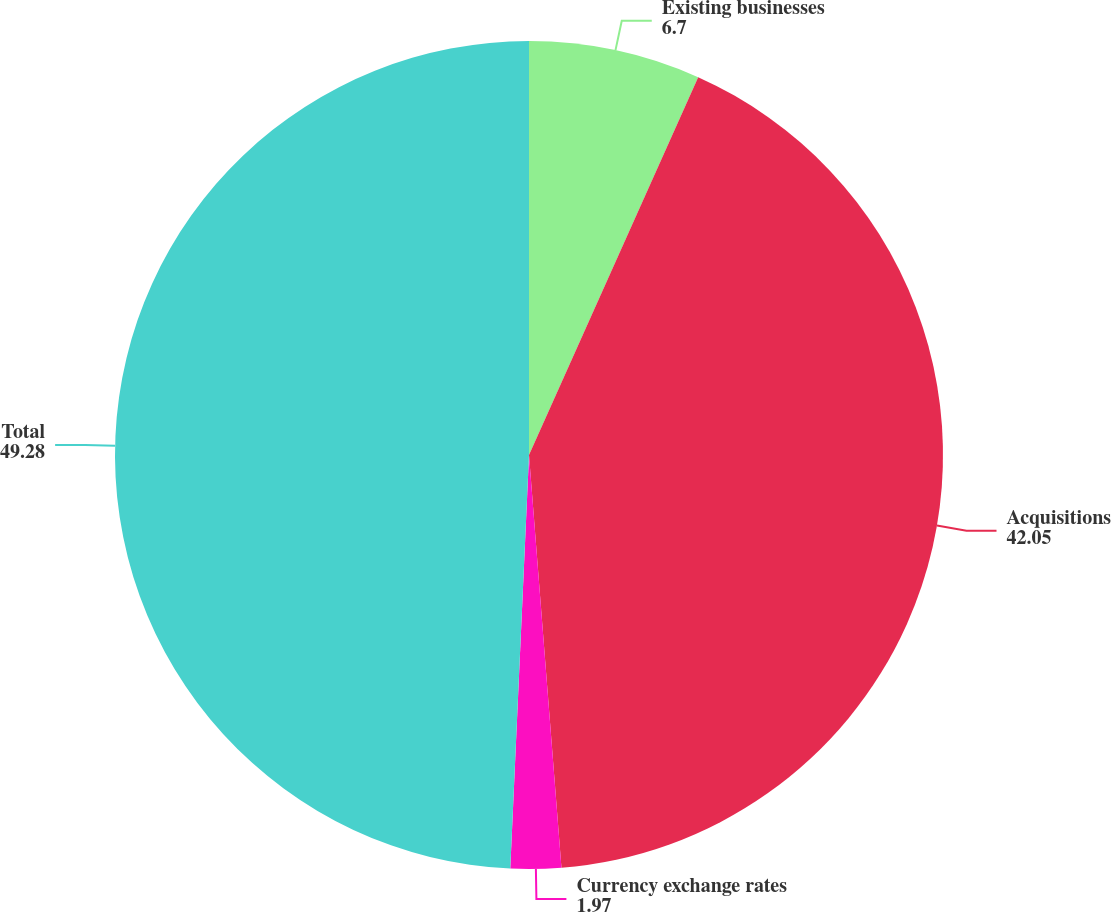Convert chart to OTSL. <chart><loc_0><loc_0><loc_500><loc_500><pie_chart><fcel>Existing businesses<fcel>Acquisitions<fcel>Currency exchange rates<fcel>Total<nl><fcel>6.7%<fcel>42.05%<fcel>1.97%<fcel>49.28%<nl></chart> 